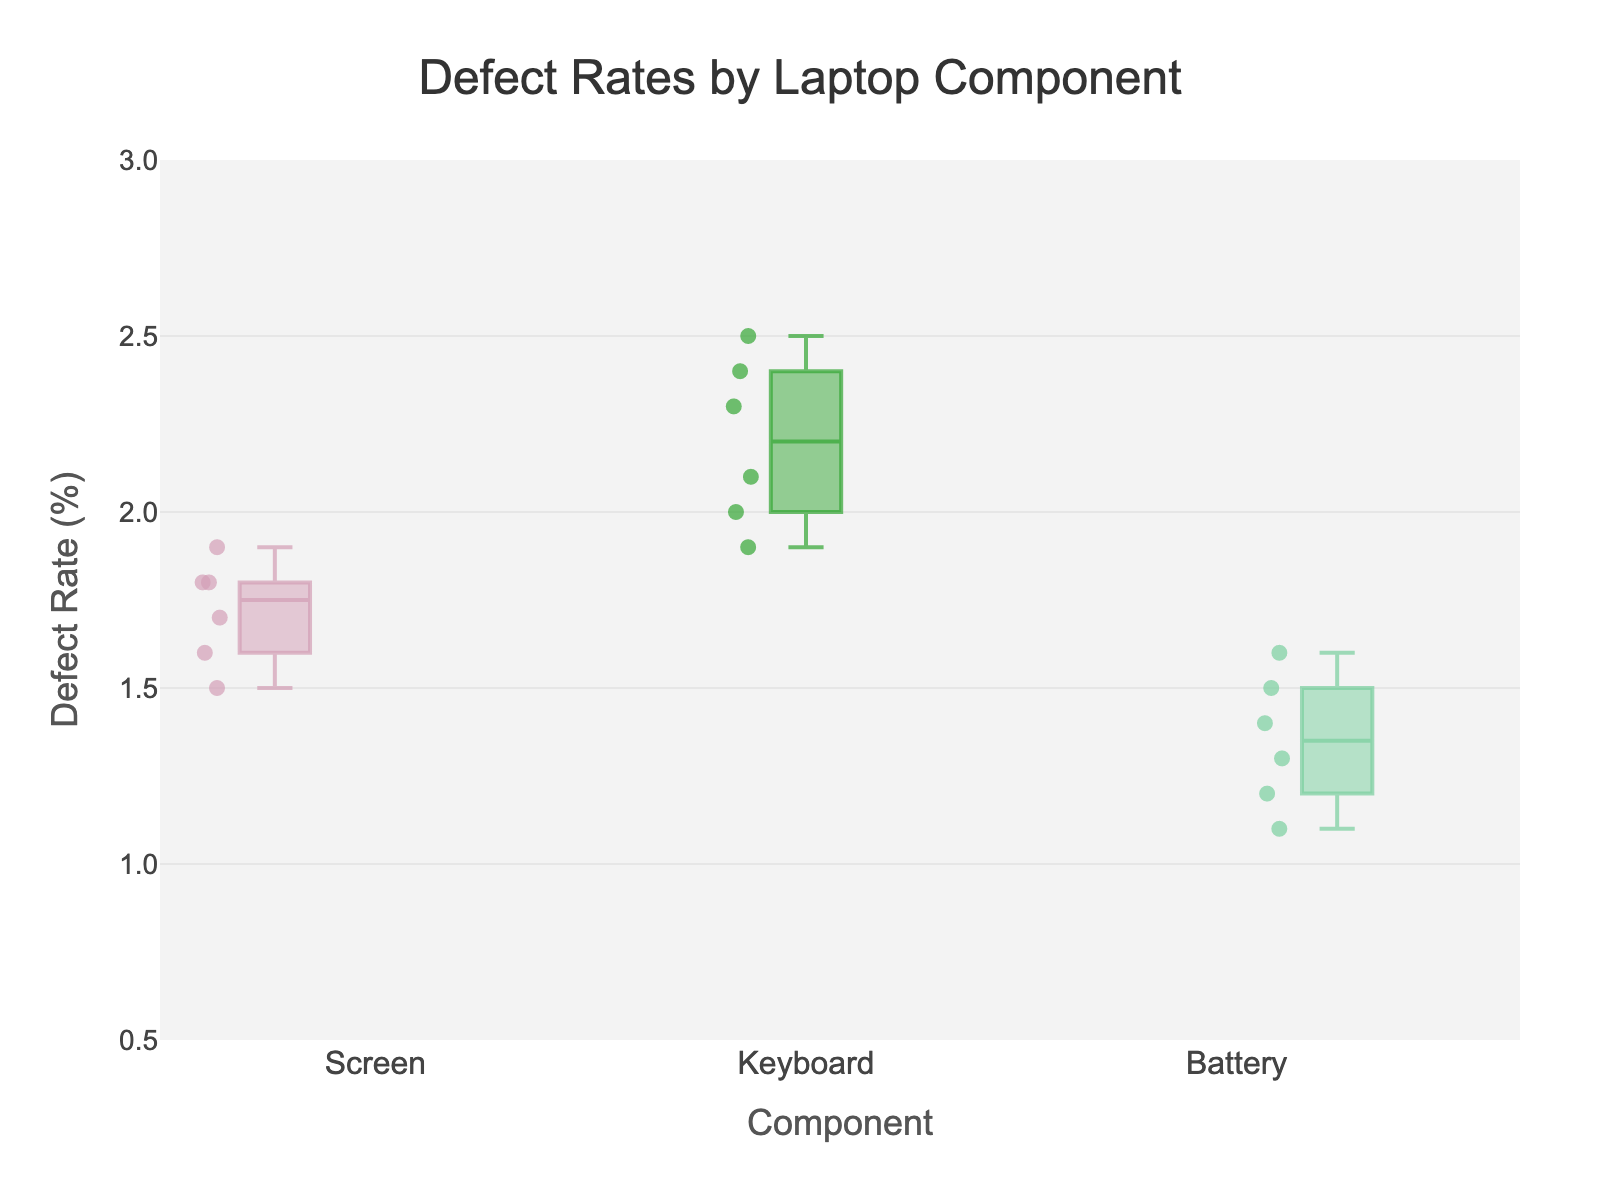What's the title of the figure? The title is usually displayed at the top of the box plot. In this case, it is clearly written as "Defect Rates by Laptop Component".
Answer: Defect Rates by Laptop Component What is the median defect rate for keyboards? To find the median of the defect rates for keyboards, look at the box representing the keyboard component. The line inside the box indicates the median. Visually estimate its value along the y-axis.
Answer: Approximately 2.2% Which component has the widest range in defect rates? To determine this, compare the length of the boxes and whiskers of each component. The component with the longest range from the bottom whisker to the top whisker has the widest range.
Answer: Keyboard What is the highest defect rate observed for the battery component? The highest defect rate can be determined by looking at the top whisker of the box for the battery component.
Answer: 1.6% Is the defect rate for screens in batch 1 higher than the median defect rate for screens overall? First, find the defect rate for screens in batch 1, which is 1.5%. Then find the median line within the screen box plot. Compare these values.
Answer: No Which component shows the most consistent defect rates across different batches? Consistency can be inferred from the length of the box. A shorter box and whiskers indicate less variability in the data.
Answer: Battery How does the defect rate range for screens compare to that for keyboards? To compare the ranges, look at the span from the bottom whisker to the top whisker for both screens and keyboards. The range for keyboards is visibly larger than that for screens.
Answer: The range for keyboards is larger What is the defect rate for the keyboard in batch 2? Find the data point or dot associated with the keyboard and labeled batch 2, and identify its position along the y-axis.
Answer: 2.5% What component has the lowest median defect rate? Check the median lines of the boxes for each component and identify the lowest one along the y-axis.
Answer: Battery Are there any outliers in the defect rates for any components? Outliers in a box plot are represented by individual points that fall outside the whiskers. Check if there are any such points for any of the components.
Answer: No 